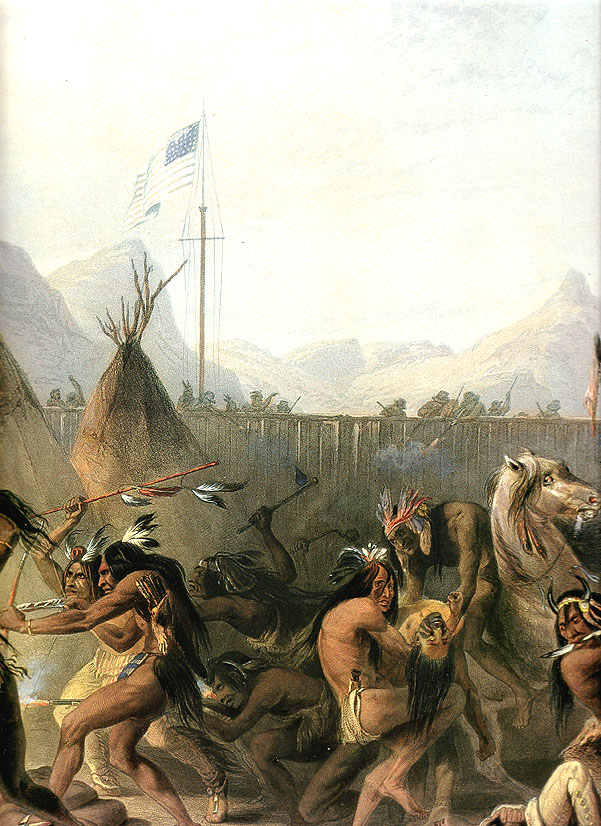What do you think is going on in this snapshot? The image is an evocative historical painting showcasing a group of Native Americans engaged in a ceremonial dance around a central flagpole, bearing an American flag. The setting is depicted with a backdrop of mountains and sparse vegetation, suggesting a remote location. The participants are adorned in traditional garments and feathered headdresses, emphasizing the cultural significance of the event. This portrayal likely serves both as a historical documentation and an artistic representation of Native American culture, particularly highlighting their interactions with symbols of American identity. The medium, oil on canvas, suggests that this scene was rendered with careful attention to detail to capture the vibrancy and movement of the dance. 